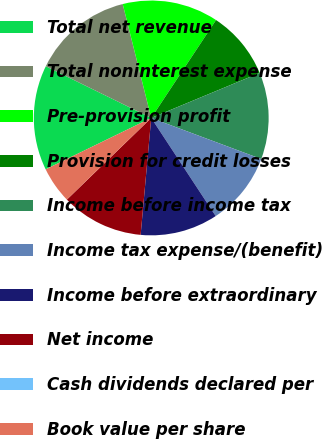<chart> <loc_0><loc_0><loc_500><loc_500><pie_chart><fcel>Total net revenue<fcel>Total noninterest expense<fcel>Pre-provision profit<fcel>Provision for credit losses<fcel>Income before income tax<fcel>Income tax expense/(benefit)<fcel>Income before extraordinary<fcel>Net income<fcel>Cash dividends declared per<fcel>Book value per share<nl><fcel>14.47%<fcel>13.84%<fcel>13.21%<fcel>9.43%<fcel>11.95%<fcel>10.06%<fcel>10.69%<fcel>11.32%<fcel>0.0%<fcel>5.03%<nl></chart> 